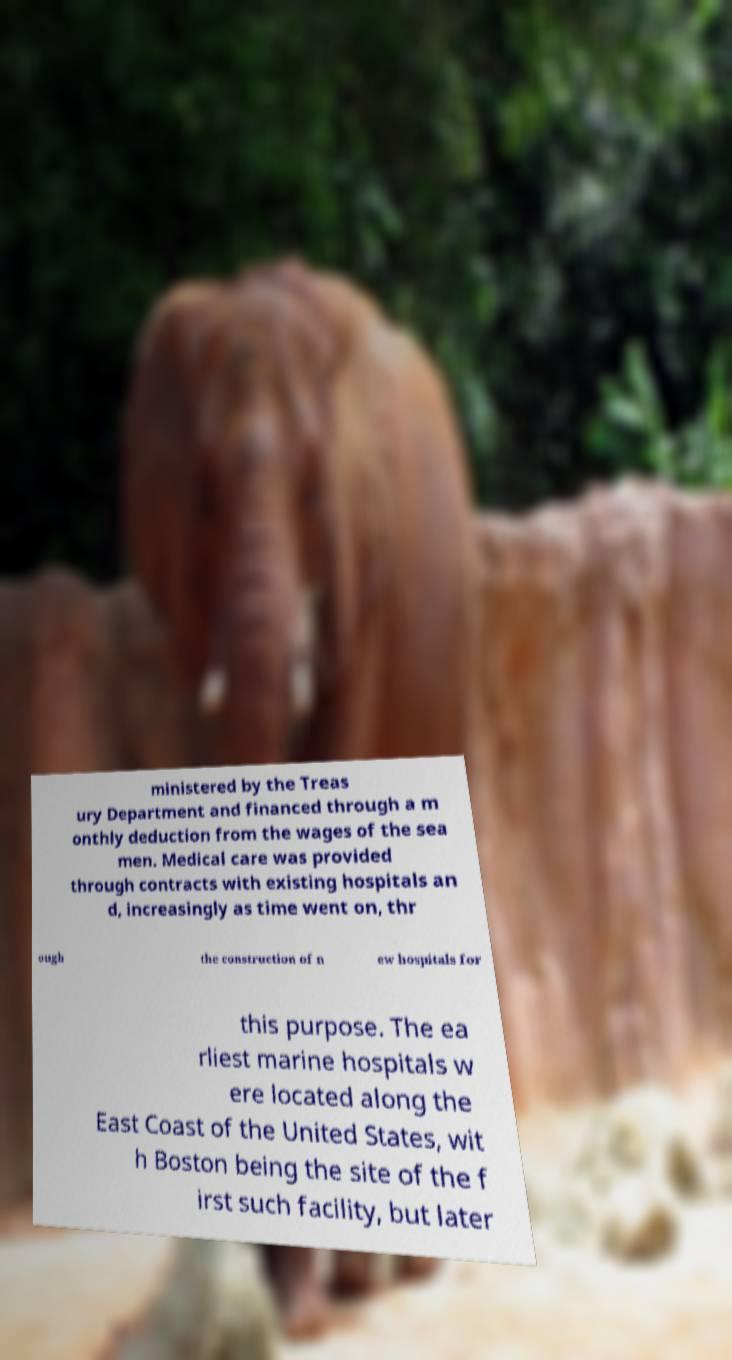Please read and relay the text visible in this image. What does it say? ministered by the Treas ury Department and financed through a m onthly deduction from the wages of the sea men. Medical care was provided through contracts with existing hospitals an d, increasingly as time went on, thr ough the construction of n ew hospitals for this purpose. The ea rliest marine hospitals w ere located along the East Coast of the United States, wit h Boston being the site of the f irst such facility, but later 